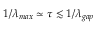<formula> <loc_0><loc_0><loc_500><loc_500>1 / \lambda _ { \max } \simeq \tau \lesssim 1 / \lambda _ { g a p }</formula> 